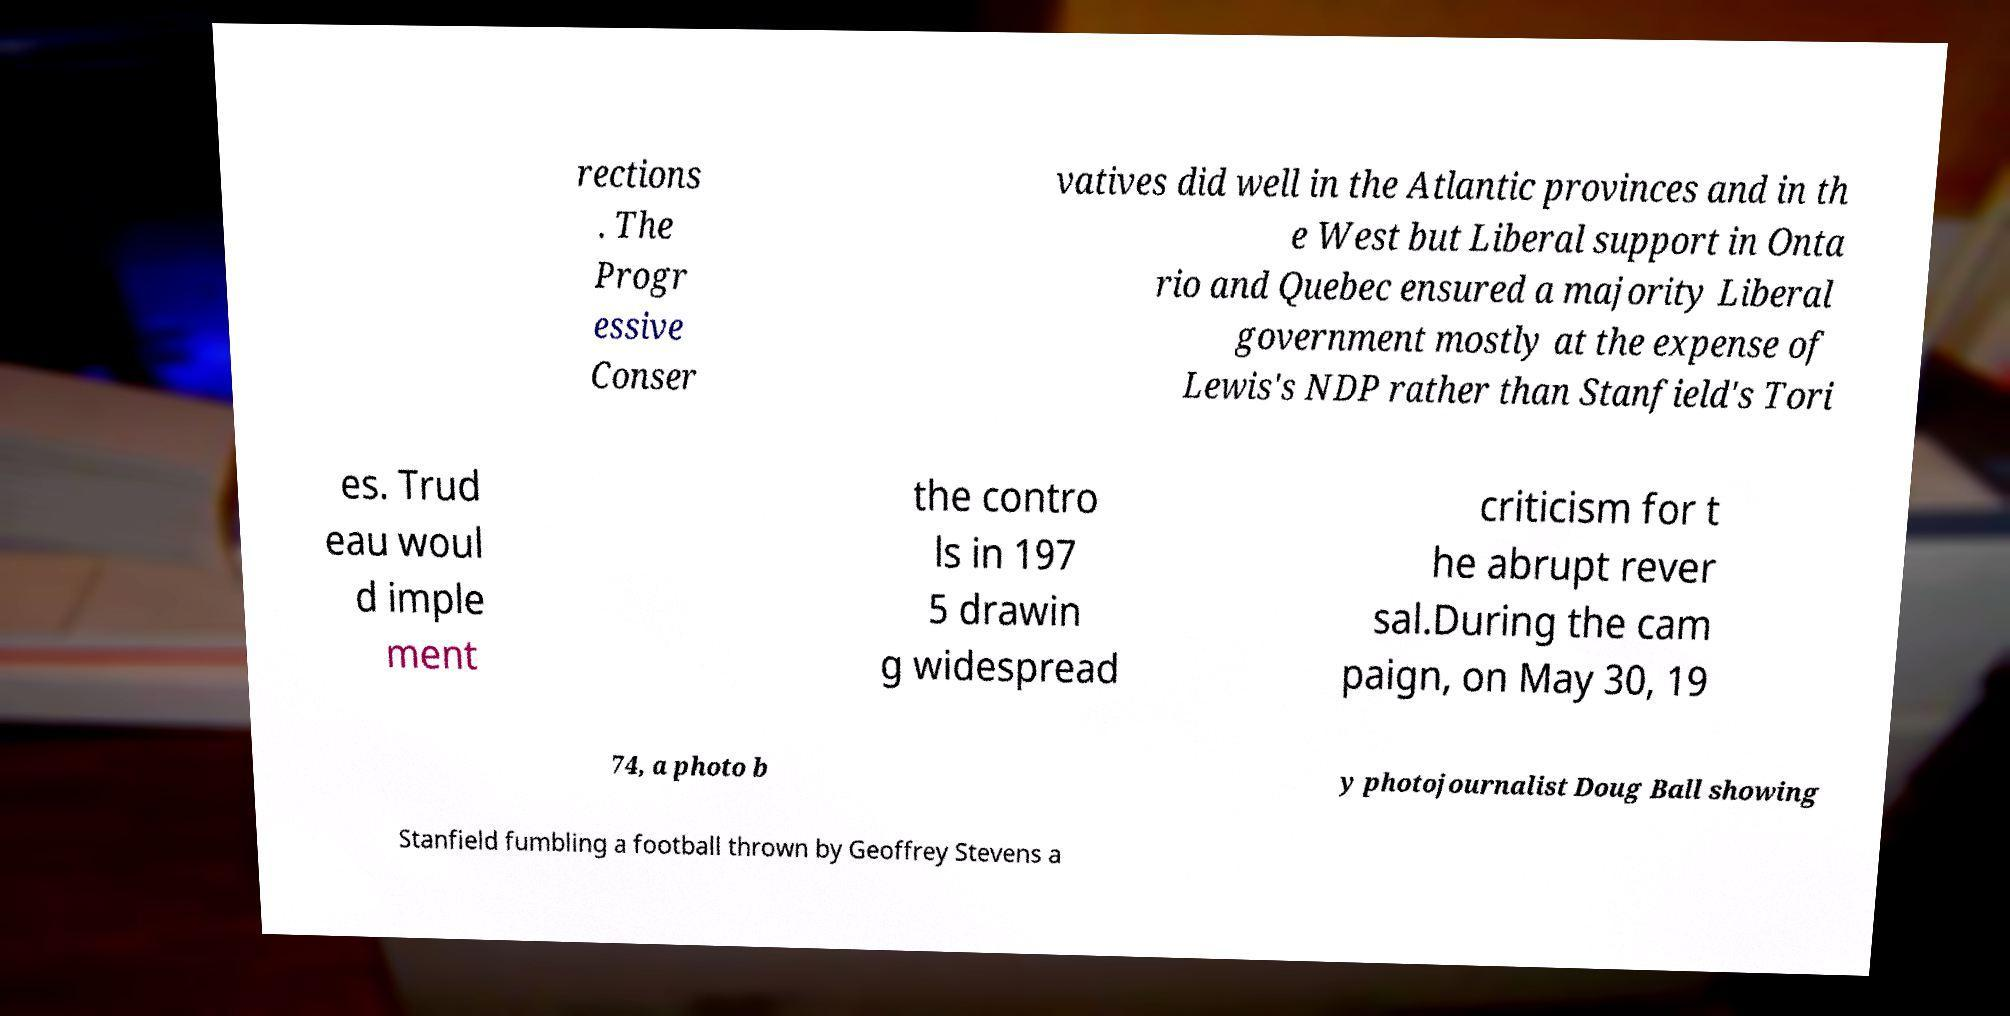Can you accurately transcribe the text from the provided image for me? rections . The Progr essive Conser vatives did well in the Atlantic provinces and in th e West but Liberal support in Onta rio and Quebec ensured a majority Liberal government mostly at the expense of Lewis's NDP rather than Stanfield's Tori es. Trud eau woul d imple ment the contro ls in 197 5 drawin g widespread criticism for t he abrupt rever sal.During the cam paign, on May 30, 19 74, a photo b y photojournalist Doug Ball showing Stanfield fumbling a football thrown by Geoffrey Stevens a 